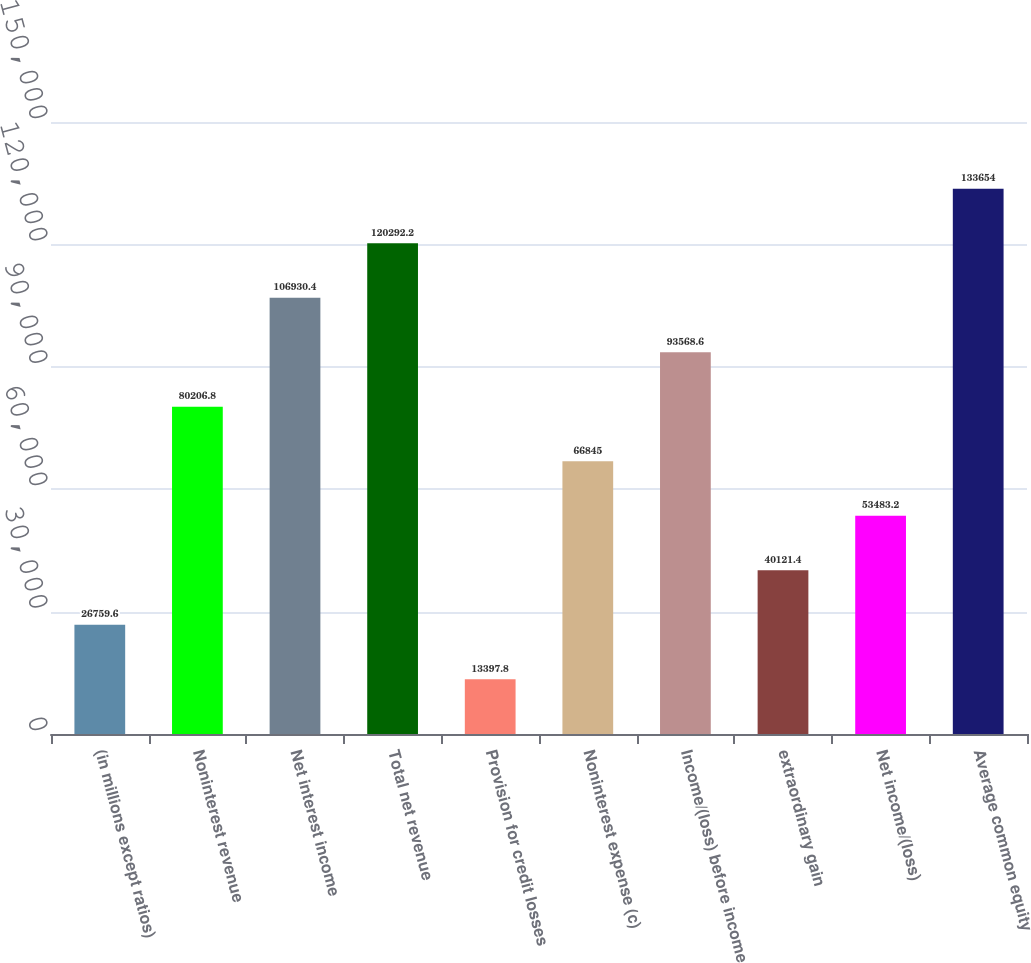Convert chart. <chart><loc_0><loc_0><loc_500><loc_500><bar_chart><fcel>(in millions except ratios)<fcel>Noninterest revenue<fcel>Net interest income<fcel>Total net revenue<fcel>Provision for credit losses<fcel>Noninterest expense (c)<fcel>Income/(loss) before income<fcel>extraordinary gain<fcel>Net income/(loss)<fcel>Average common equity<nl><fcel>26759.6<fcel>80206.8<fcel>106930<fcel>120292<fcel>13397.8<fcel>66845<fcel>93568.6<fcel>40121.4<fcel>53483.2<fcel>133654<nl></chart> 